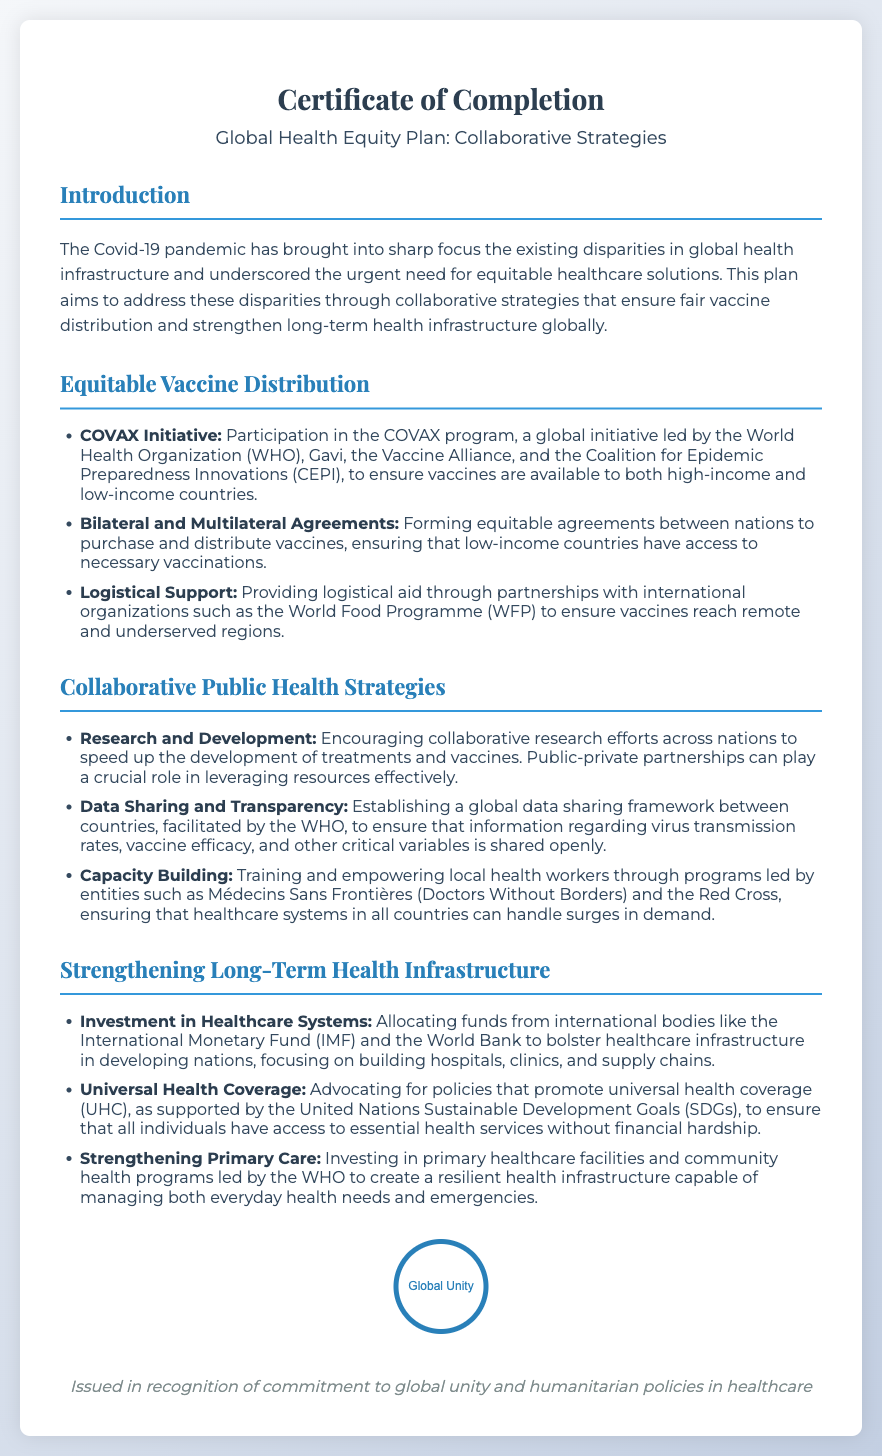What is the title of the diploma? The title of the diploma is the main heading presented prominently at the top of the document.
Answer: Global Health Equity Plan: Collaborative Strategies What organization leads the COVAX initiative? The COVAX initiative is a global effort aimed at equitable vaccine distribution, and the leading organization is identified in the document's context.
Answer: World Health Organization What does UHC stand for? UHC is an abbreviation mentioned in the context of health coverage policies discussed in the document.
Answer: Universal Health Coverage What role does the WHO have in public health strategies? The significance of the WHO is highlighted in the document, particularly in relation to global public health efforts.
Answer: Facilitating data sharing What is the focus of the health investments mentioned? The document specifies a particular area of healthcare that needs improvement through investment as part of long-term strategies.
Answer: Healthcare systems How many sections are there in the diploma? The document is structured into multiple sections, and the total number of these sections can be determined by counting them.
Answer: Four What type of strategies does the plan aim to address? The document outlines the types of strategies aimed at alleviating health disparities caused by the pandemic.
Answer: Collaborative strategies What organization mentioned assists with logistical support? One specific international organization is noted in the document responsible for aiding in logistical arrangements for vaccine distribution.
Answer: World Food Programme What is the primary goal of the Global Health Equity Plan? The document outlines the overarching aim of the plan as related to addressing health disparities, which can be summarized in a simple phrase.
Answer: Equitable healthcare solutions 